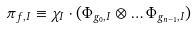<formula> <loc_0><loc_0><loc_500><loc_500>\pi _ { f , I } \equiv \chi _ { I } \cdot ( \Phi _ { g _ { 0 } , I } \otimes \dots \Phi _ { g _ { n - 1 } , I } )</formula> 